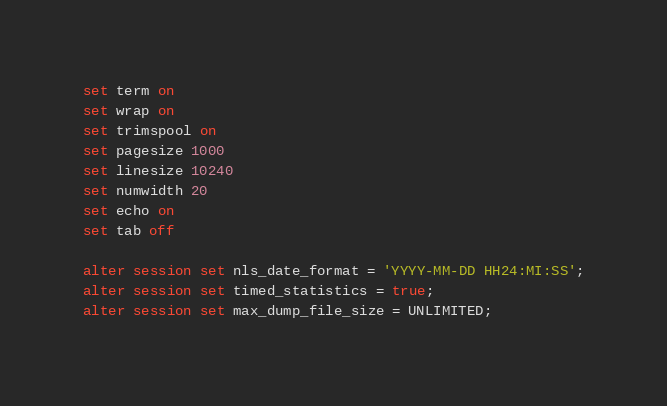Convert code to text. <code><loc_0><loc_0><loc_500><loc_500><_SQL_>set term on
set wrap on
set trimspool on
set pagesize 1000
set linesize 10240
set numwidth 20
set echo on
set tab off

alter session set nls_date_format = 'YYYY-MM-DD HH24:MI:SS';
alter session set timed_statistics = true;
alter session set max_dump_file_size = UNLIMITED;
</code> 